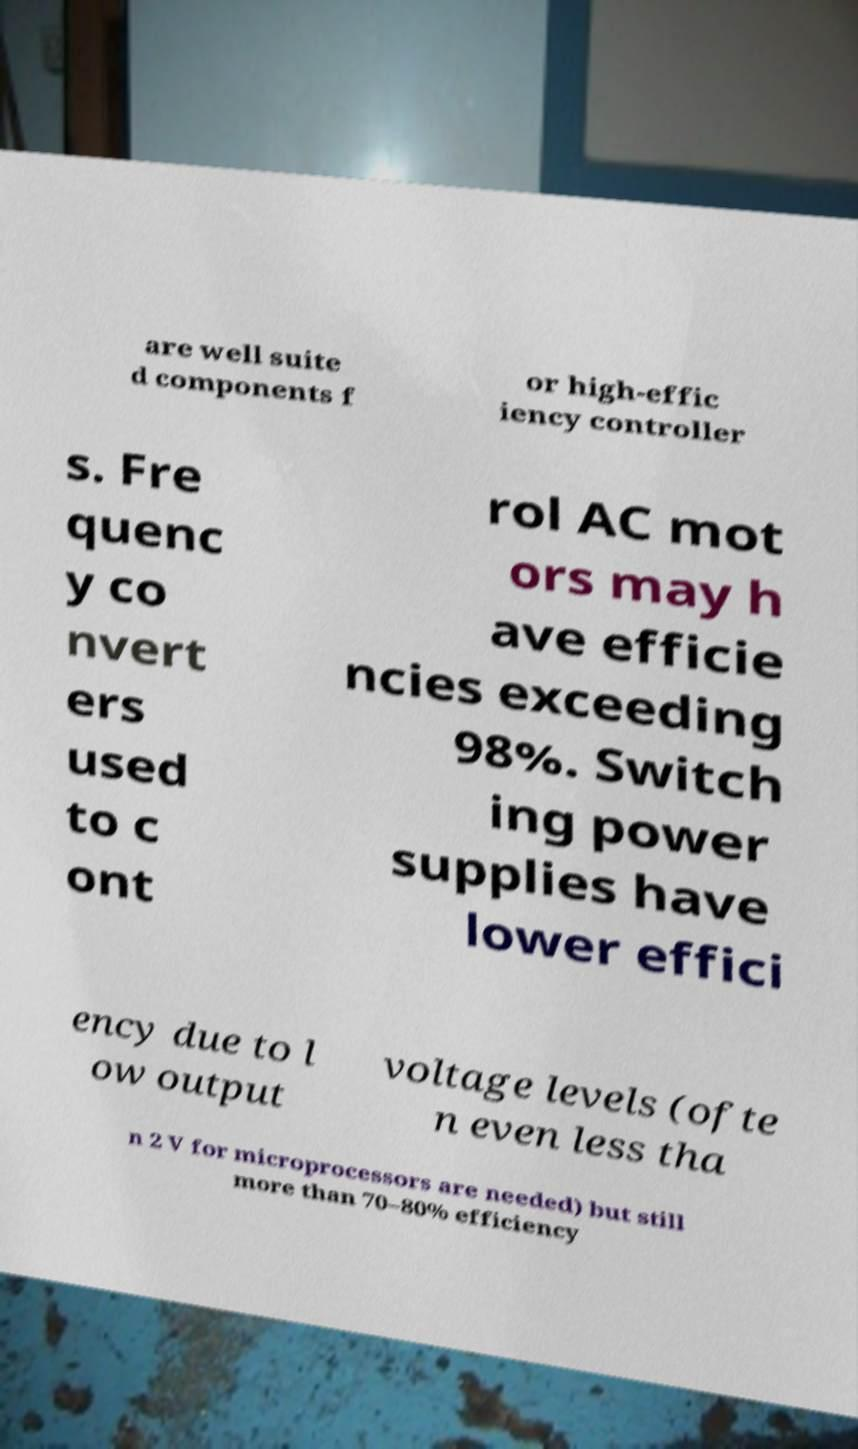What messages or text are displayed in this image? I need them in a readable, typed format. are well suite d components f or high-effic iency controller s. Fre quenc y co nvert ers used to c ont rol AC mot ors may h ave efficie ncies exceeding 98%. Switch ing power supplies have lower effici ency due to l ow output voltage levels (ofte n even less tha n 2 V for microprocessors are needed) but still more than 70–80% efficiency 